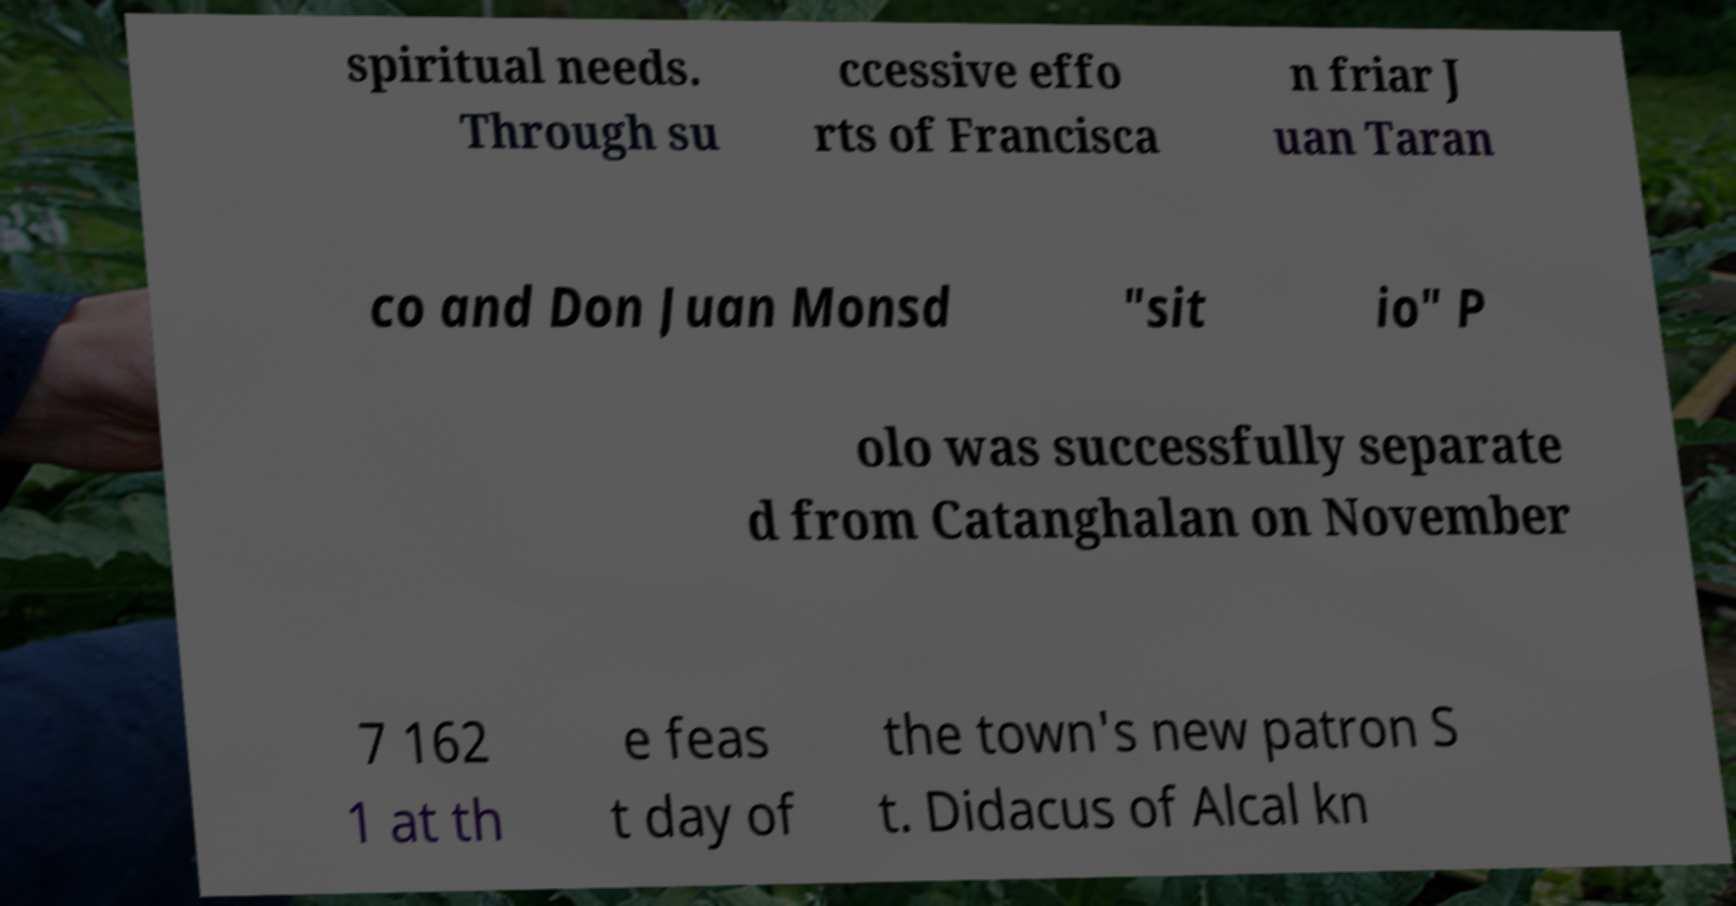Could you assist in decoding the text presented in this image and type it out clearly? spiritual needs. Through su ccessive effo rts of Francisca n friar J uan Taran co and Don Juan Monsd "sit io" P olo was successfully separate d from Catanghalan on November 7 162 1 at th e feas t day of the town's new patron S t. Didacus of Alcal kn 